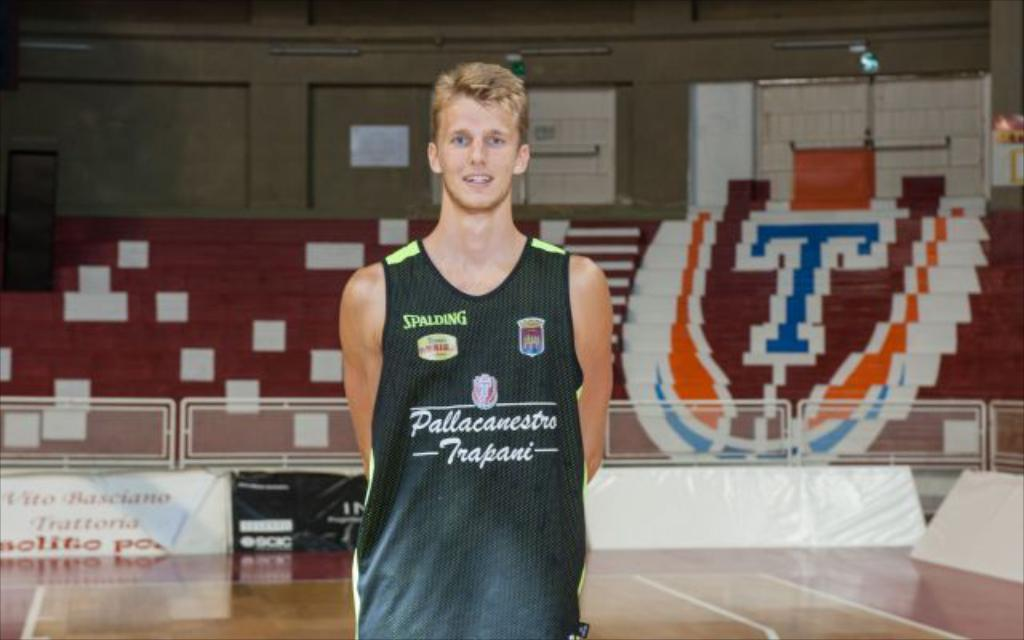<image>
Present a compact description of the photo's key features. A man wears a black shirt with advertising on it from Spalding 